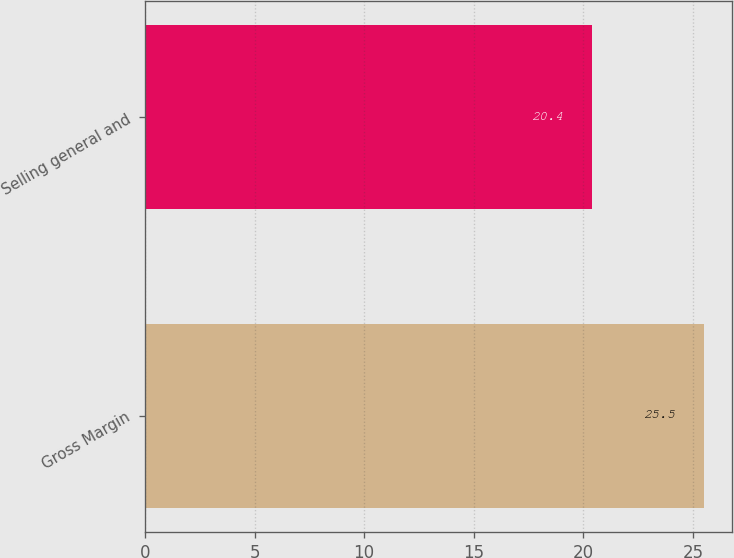Convert chart to OTSL. <chart><loc_0><loc_0><loc_500><loc_500><bar_chart><fcel>Gross Margin<fcel>Selling general and<nl><fcel>25.5<fcel>20.4<nl></chart> 